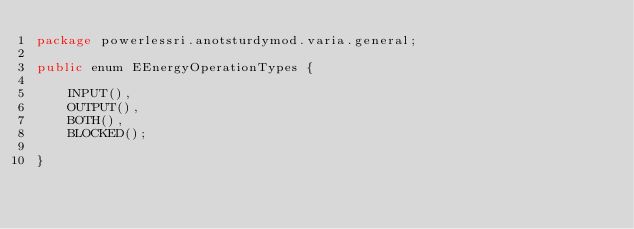<code> <loc_0><loc_0><loc_500><loc_500><_Java_>package powerlessri.anotsturdymod.varia.general;

public enum EEnergyOperationTypes {

    INPUT(),
    OUTPUT(),
    BOTH(),
    BLOCKED();

}
</code> 